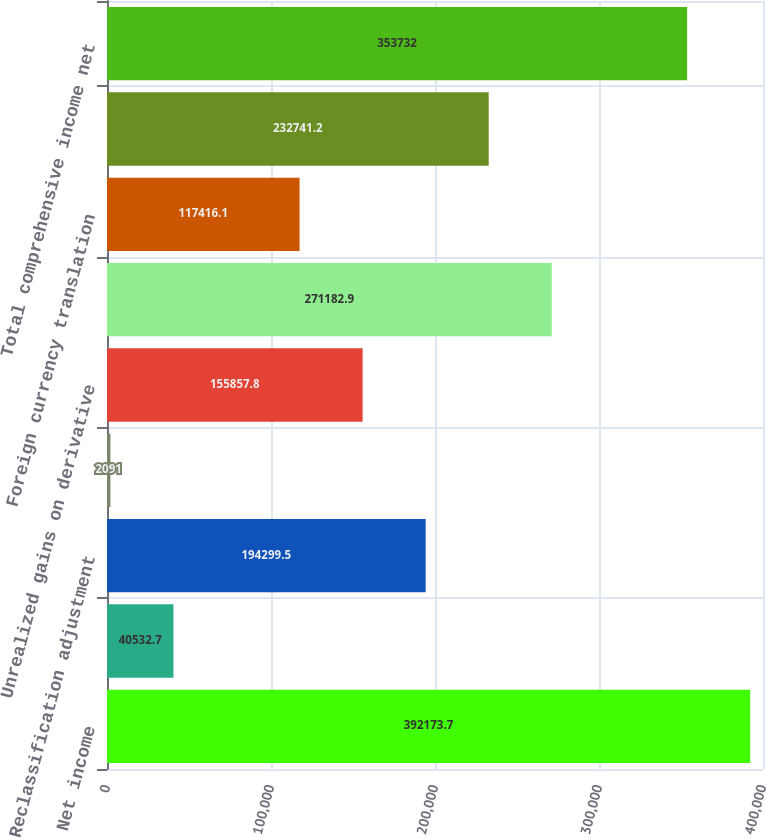Convert chart to OTSL. <chart><loc_0><loc_0><loc_500><loc_500><bar_chart><fcel>Net income<fcel>Unrealized gains (losses) on<fcel>Reclassification adjustment<fcel>Subtotal available-for-sale<fcel>Unrealized gains on derivative<fcel>Subtotal derivatives<fcel>Foreign currency translation<fcel>Other comprehensive income<fcel>Total comprehensive income net<nl><fcel>392174<fcel>40532.7<fcel>194300<fcel>2091<fcel>155858<fcel>271183<fcel>117416<fcel>232741<fcel>353732<nl></chart> 